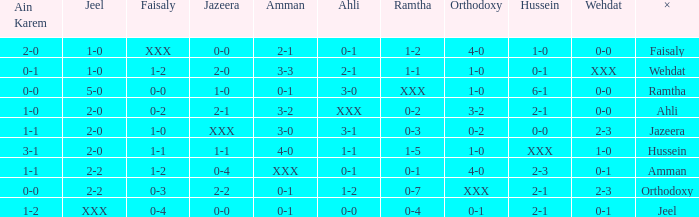What is ahli when ramtha is 0-4? 0-0. 